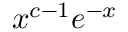Convert formula to latex. <formula><loc_0><loc_0><loc_500><loc_500>{ x ^ { c - 1 } } e ^ { - x }</formula> 